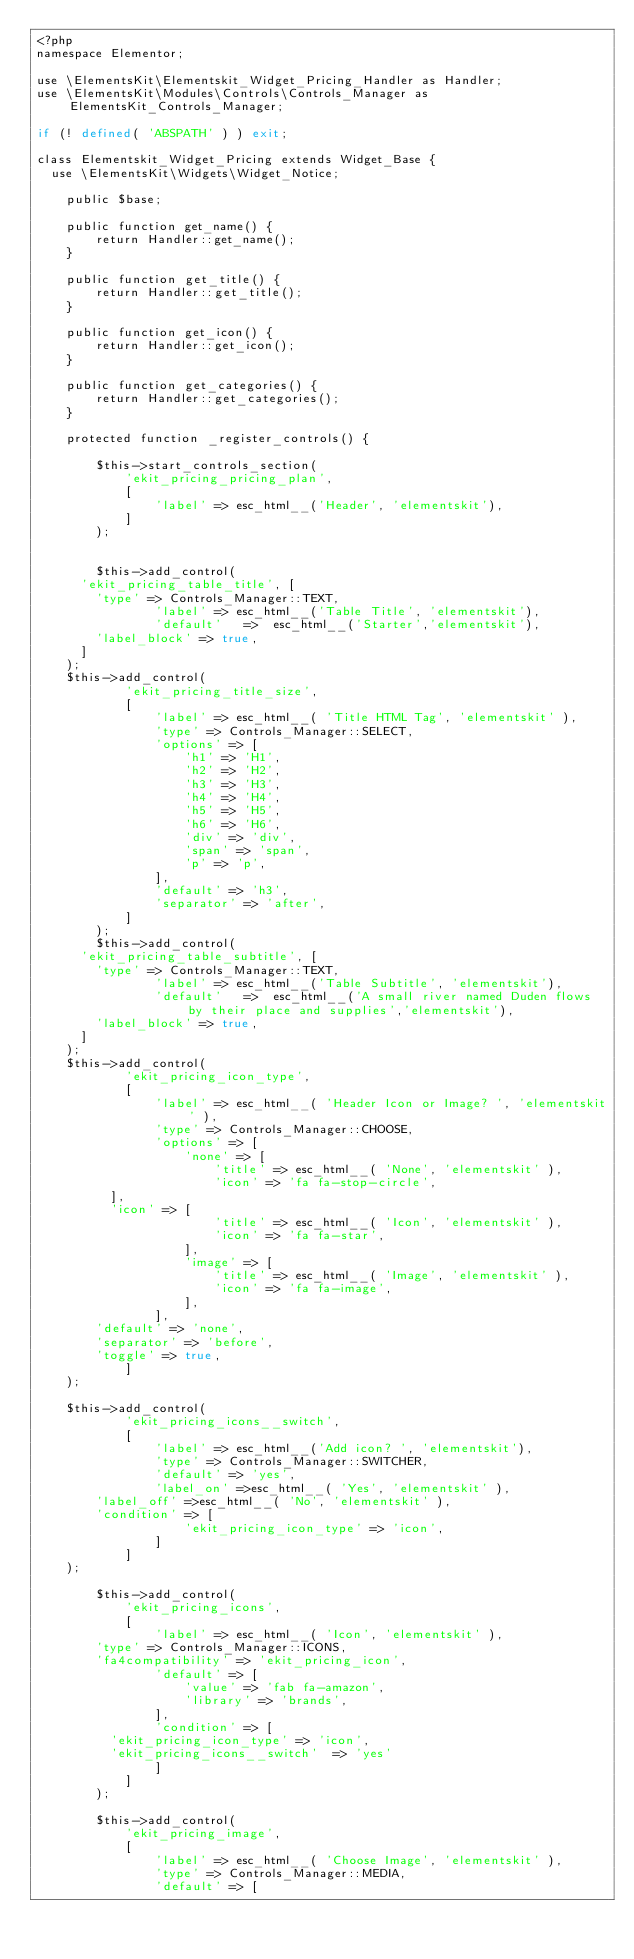Convert code to text. <code><loc_0><loc_0><loc_500><loc_500><_PHP_><?php
namespace Elementor;

use \ElementsKit\Elementskit_Widget_Pricing_Handler as Handler;
use \ElementsKit\Modules\Controls\Controls_Manager as ElementsKit_Controls_Manager;

if (! defined( 'ABSPATH' ) ) exit;

class Elementskit_Widget_Pricing extends Widget_Base {
	use \ElementsKit\Widgets\Widget_Notice;

    public $base;

    public function get_name() {
        return Handler::get_name();
    }

    public function get_title() {
        return Handler::get_title();
    }

    public function get_icon() {
        return Handler::get_icon();
    }

    public function get_categories() {
        return Handler::get_categories();
    }

    protected function _register_controls() {

        $this->start_controls_section(
            'ekit_pricing_pricing_plan',
            [
                'label' => esc_html__('Header', 'elementskit'),
            ]
        );


        $this->add_control(
			'ekit_pricing_table_title', [
				'type' => Controls_Manager::TEXT,
                'label' => esc_html__('Table Title', 'elementskit'),
                'default'   =>  esc_html__('Starter','elementskit'),
				'label_block' => true,
			]
		);
		$this->add_control(
            'ekit_pricing_title_size',
            [
                'label' => esc_html__( 'Title HTML Tag', 'elementskit' ),
                'type' => Controls_Manager::SELECT,
                'options' => [
                    'h1' => 'H1',
                    'h2' => 'H2',
                    'h3' => 'H3',
                    'h4' => 'H4',
                    'h5' => 'H5',
                    'h6' => 'H6',
                    'div' => 'div',
                    'span' => 'span',
                    'p' => 'p',
                ],
                'default' => 'h3',
                'separator' => 'after',
            ]
        );
        $this->add_control(
			'ekit_pricing_table_subtitle', [
				'type' => Controls_Manager::TEXT,
                'label' => esc_html__('Table Subtitle', 'elementskit'),
                'default'   =>  esc_html__('A small river named Duden flows by their place and supplies','elementskit'),
				'label_block' => true,
			]
		);
		$this->add_control(
            'ekit_pricing_icon_type',
            [
                'label' => esc_html__( 'Header Icon or Image? ', 'elementskit' ),
                'type' => Controls_Manager::CHOOSE,
                'options' => [
                    'none' => [
                        'title' => esc_html__( 'None', 'elementskit' ),
                        'icon' => 'fa fa-stop-circle',
					],
					'icon' => [
                        'title' => esc_html__( 'Icon', 'elementskit' ),
                        'icon' => 'fa fa-star',
                    ],
                    'image' => [
                        'title' => esc_html__( 'Image', 'elementskit' ),
                        'icon' => 'fa fa-image',
                    ],
                ],
				'default' => 'none',
				'separator' => 'before',
				'toggle' => true,
            ]
		);
		
		$this->add_control(
            'ekit_pricing_icons__switch',
            [
                'label' => esc_html__('Add icon? ', 'elementskit'),
                'type' => Controls_Manager::SWITCHER,
                'default' => 'yes',
                'label_on' =>esc_html__( 'Yes', 'elementskit' ),
				'label_off' =>esc_html__( 'No', 'elementskit' ),
				'condition' => [
                    'ekit_pricing_icon_type' => 'icon',
                ]
            ]
		);

        $this->add_control(
            'ekit_pricing_icons',
            [
                'label' => esc_html__( 'Icon', 'elementskit' ),
				'type' => Controls_Manager::ICONS,
				'fa4compatibility' => 'ekit_pricing_icon',
                'default' => [
                    'value' => 'fab fa-amazon',
                    'library' => 'brands',
                ],
                'condition' => [
					'ekit_pricing_icon_type' => 'icon',
					'ekit_pricing_icons__switch'	=> 'yes'
                ]
            ]
        );

        $this->add_control(
            'ekit_pricing_image',
            [
                'label' => esc_html__( 'Choose Image', 'elementskit' ),
                'type' => Controls_Manager::MEDIA,
                'default' => [</code> 